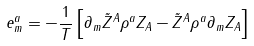Convert formula to latex. <formula><loc_0><loc_0><loc_500><loc_500>e _ { m } ^ { a } = - { \frac { 1 } { T } } \left [ \partial _ { m } \tilde { Z } ^ { A } \rho ^ { a } Z _ { A } - \tilde { Z } ^ { A } \rho ^ { a } \partial _ { m } Z _ { A } \right ]</formula> 